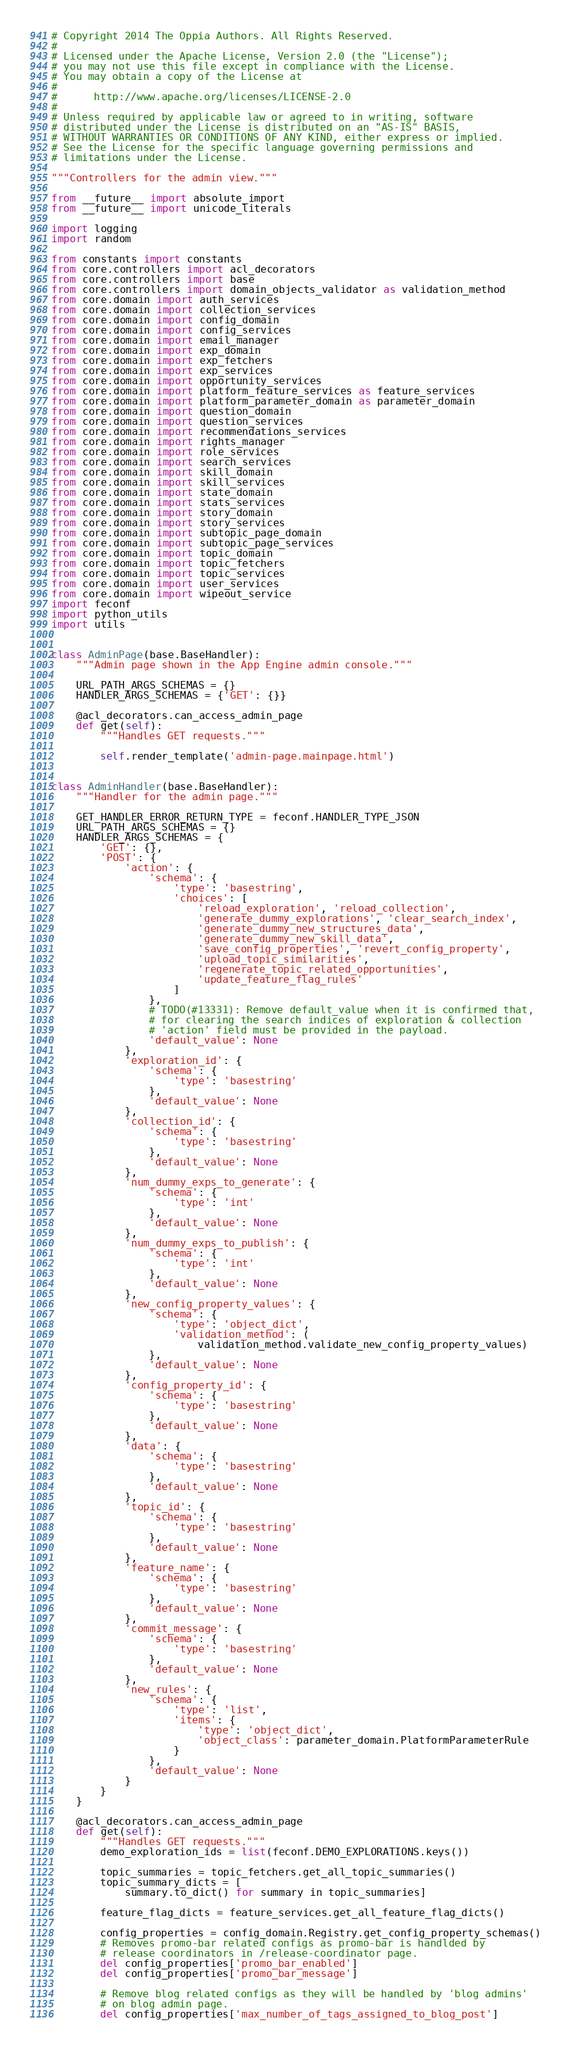<code> <loc_0><loc_0><loc_500><loc_500><_Python_># Copyright 2014 The Oppia Authors. All Rights Reserved.
#
# Licensed under the Apache License, Version 2.0 (the "License");
# you may not use this file except in compliance with the License.
# You may obtain a copy of the License at
#
#      http://www.apache.org/licenses/LICENSE-2.0
#
# Unless required by applicable law or agreed to in writing, software
# distributed under the License is distributed on an "AS-IS" BASIS,
# WITHOUT WARRANTIES OR CONDITIONS OF ANY KIND, either express or implied.
# See the License for the specific language governing permissions and
# limitations under the License.

"""Controllers for the admin view."""

from __future__ import absolute_import
from __future__ import unicode_literals

import logging
import random

from constants import constants
from core.controllers import acl_decorators
from core.controllers import base
from core.controllers import domain_objects_validator as validation_method
from core.domain import auth_services
from core.domain import collection_services
from core.domain import config_domain
from core.domain import config_services
from core.domain import email_manager
from core.domain import exp_domain
from core.domain import exp_fetchers
from core.domain import exp_services
from core.domain import opportunity_services
from core.domain import platform_feature_services as feature_services
from core.domain import platform_parameter_domain as parameter_domain
from core.domain import question_domain
from core.domain import question_services
from core.domain import recommendations_services
from core.domain import rights_manager
from core.domain import role_services
from core.domain import search_services
from core.domain import skill_domain
from core.domain import skill_services
from core.domain import state_domain
from core.domain import stats_services
from core.domain import story_domain
from core.domain import story_services
from core.domain import subtopic_page_domain
from core.domain import subtopic_page_services
from core.domain import topic_domain
from core.domain import topic_fetchers
from core.domain import topic_services
from core.domain import user_services
from core.domain import wipeout_service
import feconf
import python_utils
import utils


class AdminPage(base.BaseHandler):
    """Admin page shown in the App Engine admin console."""

    URL_PATH_ARGS_SCHEMAS = {}
    HANDLER_ARGS_SCHEMAS = {'GET': {}}

    @acl_decorators.can_access_admin_page
    def get(self):
        """Handles GET requests."""

        self.render_template('admin-page.mainpage.html')


class AdminHandler(base.BaseHandler):
    """Handler for the admin page."""

    GET_HANDLER_ERROR_RETURN_TYPE = feconf.HANDLER_TYPE_JSON
    URL_PATH_ARGS_SCHEMAS = {}
    HANDLER_ARGS_SCHEMAS = {
        'GET': {},
        'POST': {
            'action': {
                'schema': {
                    'type': 'basestring',
                    'choices': [
                        'reload_exploration', 'reload_collection',
                        'generate_dummy_explorations', 'clear_search_index',
                        'generate_dummy_new_structures_data',
                        'generate_dummy_new_skill_data',
                        'save_config_properties', 'revert_config_property',
                        'upload_topic_similarities',
                        'regenerate_topic_related_opportunities',
                        'update_feature_flag_rules'
                    ]
                },
                # TODO(#13331): Remove default_value when it is confirmed that,
                # for clearing the search indices of exploration & collection
                # 'action' field must be provided in the payload.
                'default_value': None
            },
            'exploration_id': {
                'schema': {
                    'type': 'basestring'
                },
                'default_value': None
            },
            'collection_id': {
                'schema': {
                    'type': 'basestring'
                },
                'default_value': None
            },
            'num_dummy_exps_to_generate': {
                'schema': {
                    'type': 'int'
                },
                'default_value': None
            },
            'num_dummy_exps_to_publish': {
                'schema': {
                    'type': 'int'
                },
                'default_value': None
            },
            'new_config_property_values': {
                'schema': {
                    'type': 'object_dict',
                    'validation_method': (
                        validation_method.validate_new_config_property_values)
                },
                'default_value': None
            },
            'config_property_id': {
                'schema': {
                    'type': 'basestring'
                },
                'default_value': None
            },
            'data': {
                'schema': {
                    'type': 'basestring'
                },
                'default_value': None
            },
            'topic_id': {
                'schema': {
                    'type': 'basestring'
                },
                'default_value': None
            },
            'feature_name': {
                'schema': {
                    'type': 'basestring'
                },
                'default_value': None
            },
            'commit_message': {
                'schema': {
                    'type': 'basestring'
                },
                'default_value': None
            },
            'new_rules': {
                'schema': {
                    'type': 'list',
                    'items': {
                        'type': 'object_dict',
                        'object_class': parameter_domain.PlatformParameterRule
                    }
                },
                'default_value': None
            }
        }
    }

    @acl_decorators.can_access_admin_page
    def get(self):
        """Handles GET requests."""
        demo_exploration_ids = list(feconf.DEMO_EXPLORATIONS.keys())

        topic_summaries = topic_fetchers.get_all_topic_summaries()
        topic_summary_dicts = [
            summary.to_dict() for summary in topic_summaries]

        feature_flag_dicts = feature_services.get_all_feature_flag_dicts()

        config_properties = config_domain.Registry.get_config_property_schemas()
        # Removes promo-bar related configs as promo-bar is handlded by
        # release coordinators in /release-coordinator page.
        del config_properties['promo_bar_enabled']
        del config_properties['promo_bar_message']

        # Remove blog related configs as they will be handled by 'blog admins'
        # on blog admin page.
        del config_properties['max_number_of_tags_assigned_to_blog_post']</code> 